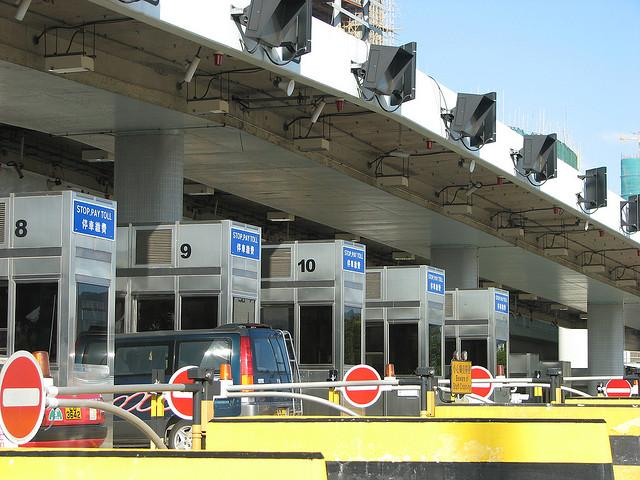What does the red sign with a minus symbol on it usually mean? no entry 